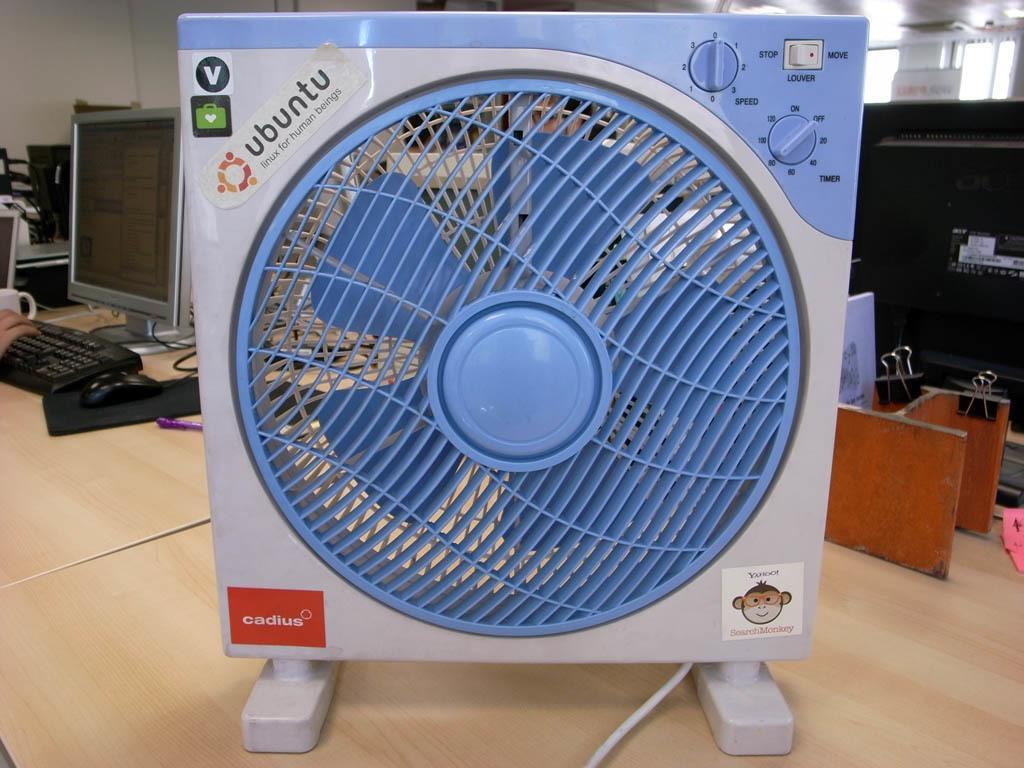Could you give a brief overview of what you see in this image? In this image I can see there is a person's hand working on the computer. And there is a cooler placed on the table. And there are some objects on it. And at the back there is a window and a wall. 